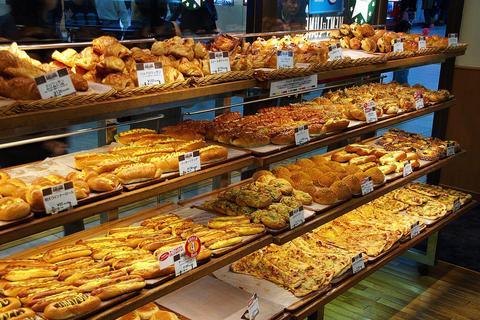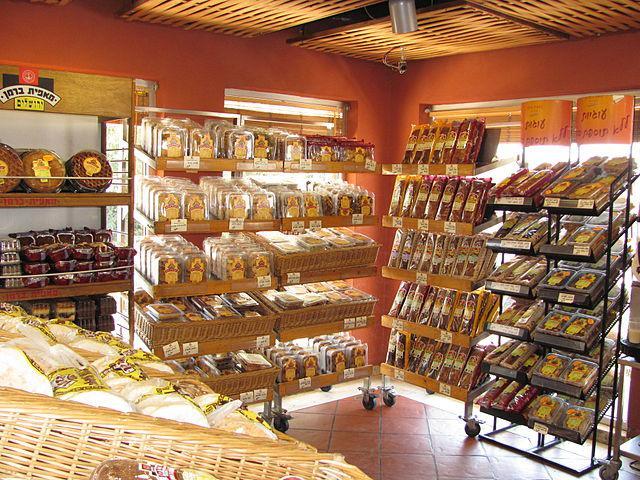The first image is the image on the left, the second image is the image on the right. Evaluate the accuracy of this statement regarding the images: "At least one image shows a uniformed bakery worker.". Is it true? Answer yes or no. No. The first image is the image on the left, the second image is the image on the right. Assess this claim about the two images: "In 1 of the images, a person is near bread.". Correct or not? Answer yes or no. No. 